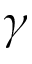Convert formula to latex. <formula><loc_0><loc_0><loc_500><loc_500>\gamma</formula> 